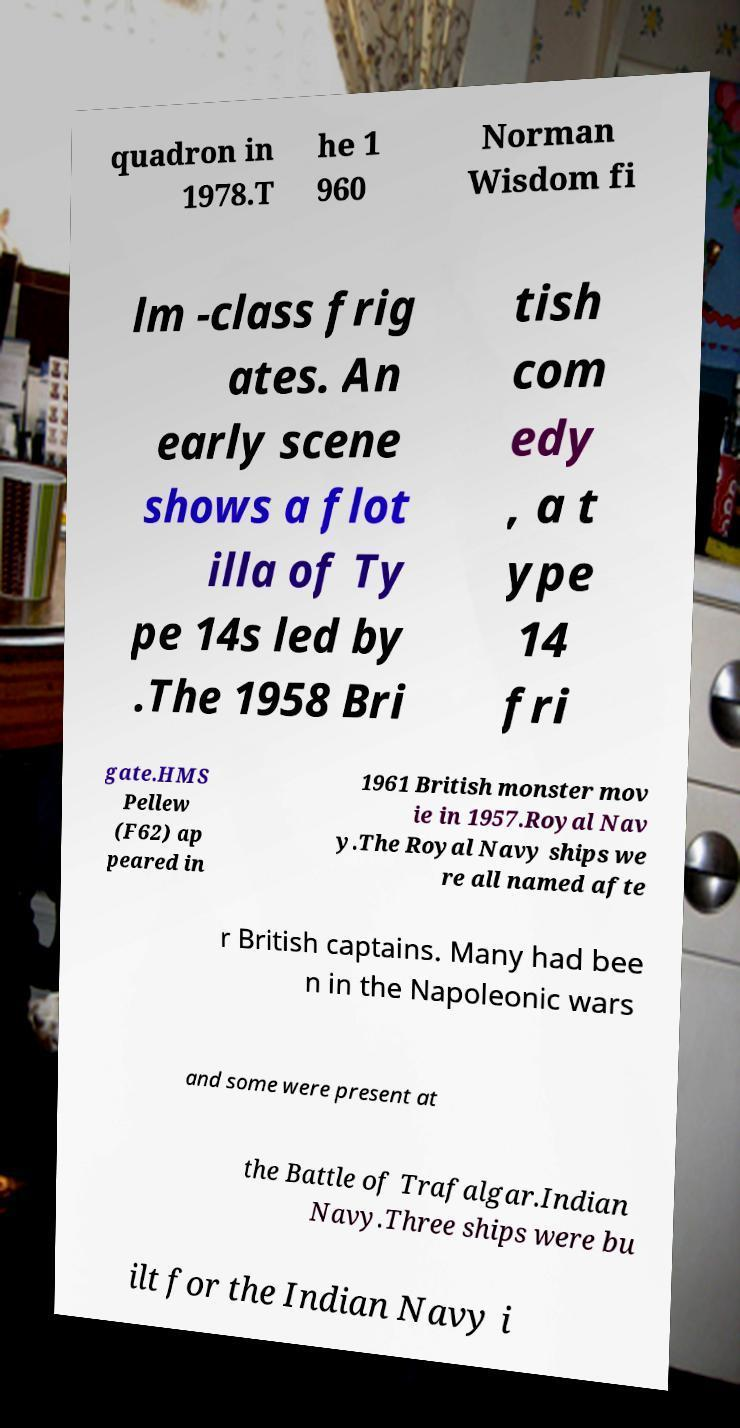Could you assist in decoding the text presented in this image and type it out clearly? quadron in 1978.T he 1 960 Norman Wisdom fi lm -class frig ates. An early scene shows a flot illa of Ty pe 14s led by .The 1958 Bri tish com edy , a t ype 14 fri gate.HMS Pellew (F62) ap peared in 1961 British monster mov ie in 1957.Royal Nav y.The Royal Navy ships we re all named afte r British captains. Many had bee n in the Napoleonic wars and some were present at the Battle of Trafalgar.Indian Navy.Three ships were bu ilt for the Indian Navy i 